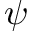<formula> <loc_0><loc_0><loc_500><loc_500>\psi</formula> 